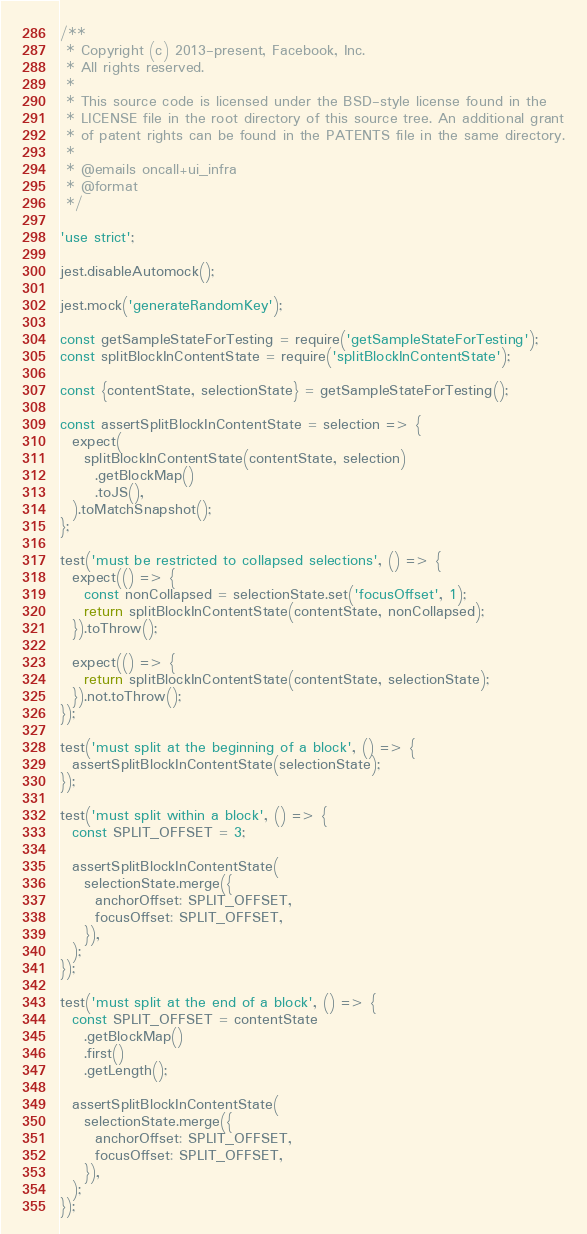<code> <loc_0><loc_0><loc_500><loc_500><_JavaScript_>/**
 * Copyright (c) 2013-present, Facebook, Inc.
 * All rights reserved.
 *
 * This source code is licensed under the BSD-style license found in the
 * LICENSE file in the root directory of this source tree. An additional grant
 * of patent rights can be found in the PATENTS file in the same directory.
 *
 * @emails oncall+ui_infra
 * @format
 */

'use strict';

jest.disableAutomock();

jest.mock('generateRandomKey');

const getSampleStateForTesting = require('getSampleStateForTesting');
const splitBlockInContentState = require('splitBlockInContentState');

const {contentState, selectionState} = getSampleStateForTesting();

const assertSplitBlockInContentState = selection => {
  expect(
    splitBlockInContentState(contentState, selection)
      .getBlockMap()
      .toJS(),
  ).toMatchSnapshot();
};

test('must be restricted to collapsed selections', () => {
  expect(() => {
    const nonCollapsed = selectionState.set('focusOffset', 1);
    return splitBlockInContentState(contentState, nonCollapsed);
  }).toThrow();

  expect(() => {
    return splitBlockInContentState(contentState, selectionState);
  }).not.toThrow();
});

test('must split at the beginning of a block', () => {
  assertSplitBlockInContentState(selectionState);
});

test('must split within a block', () => {
  const SPLIT_OFFSET = 3;

  assertSplitBlockInContentState(
    selectionState.merge({
      anchorOffset: SPLIT_OFFSET,
      focusOffset: SPLIT_OFFSET,
    }),
  );
});

test('must split at the end of a block', () => {
  const SPLIT_OFFSET = contentState
    .getBlockMap()
    .first()
    .getLength();

  assertSplitBlockInContentState(
    selectionState.merge({
      anchorOffset: SPLIT_OFFSET,
      focusOffset: SPLIT_OFFSET,
    }),
  );
});
</code> 